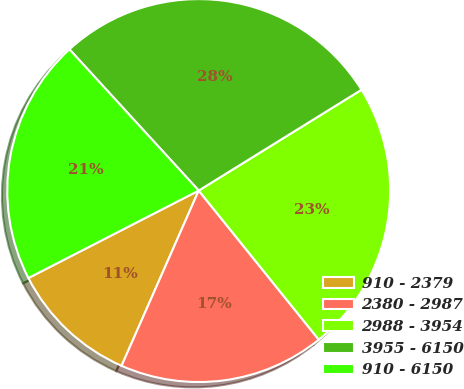Convert chart to OTSL. <chart><loc_0><loc_0><loc_500><loc_500><pie_chart><fcel>910 - 2379<fcel>2380 - 2987<fcel>2988 - 3954<fcel>3955 - 6150<fcel>910 - 6150<nl><fcel>10.85%<fcel>17.39%<fcel>23.03%<fcel>27.97%<fcel>20.75%<nl></chart> 